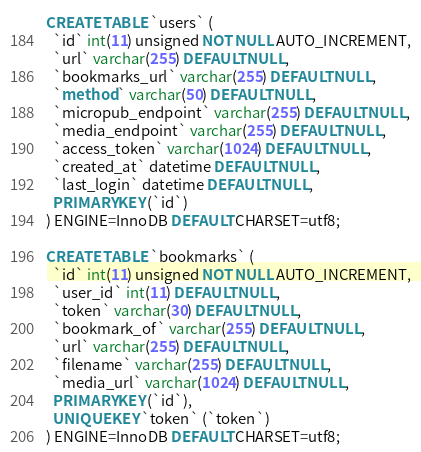<code> <loc_0><loc_0><loc_500><loc_500><_SQL_>CREATE TABLE `users` (
  `id` int(11) unsigned NOT NULL AUTO_INCREMENT,
  `url` varchar(255) DEFAULT NULL,
  `bookmarks_url` varchar(255) DEFAULT NULL,
  `method` varchar(50) DEFAULT NULL,
  `micropub_endpoint` varchar(255) DEFAULT NULL,
  `media_endpoint` varchar(255) DEFAULT NULL,
  `access_token` varchar(1024) DEFAULT NULL,
  `created_at` datetime DEFAULT NULL,
  `last_login` datetime DEFAULT NULL,
  PRIMARY KEY (`id`)
) ENGINE=InnoDB DEFAULT CHARSET=utf8;

CREATE TABLE `bookmarks` (
  `id` int(11) unsigned NOT NULL AUTO_INCREMENT,
  `user_id` int(11) DEFAULT NULL,
  `token` varchar(30) DEFAULT NULL,
  `bookmark_of` varchar(255) DEFAULT NULL,
  `url` varchar(255) DEFAULT NULL,
  `filename` varchar(255) DEFAULT NULL,
  `media_url` varchar(1024) DEFAULT NULL,
  PRIMARY KEY (`id`),
  UNIQUE KEY `token` (`token`)
) ENGINE=InnoDB DEFAULT CHARSET=utf8;
</code> 